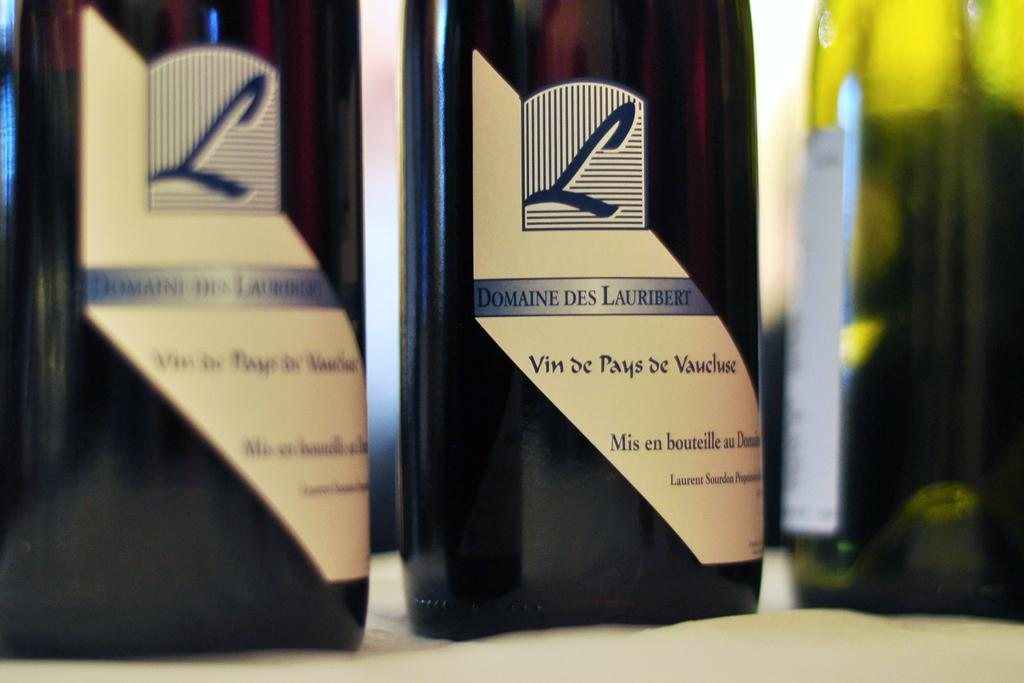<image>
Share a concise interpretation of the image provided. Two bottles L Domaines Des Lauribert sit on a table. 